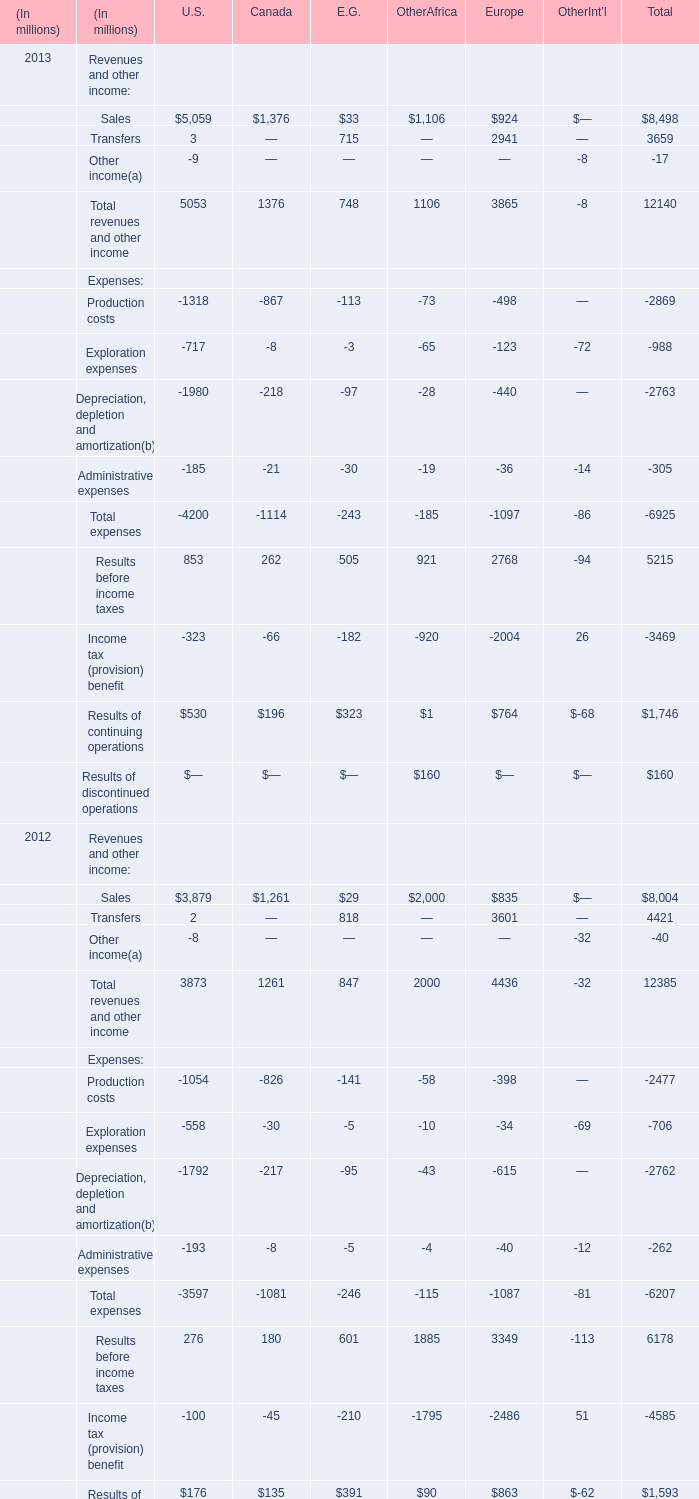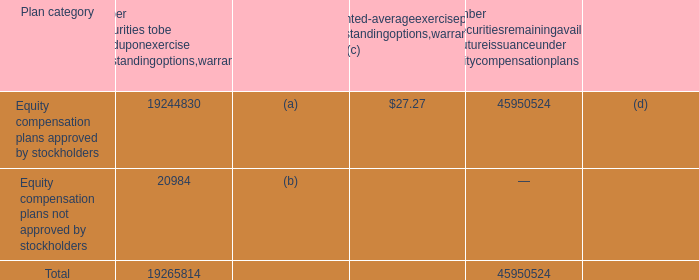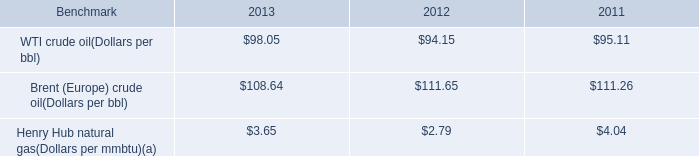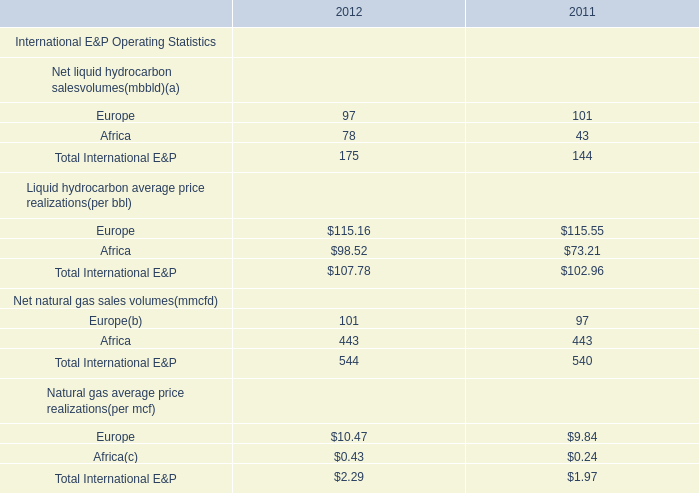by what percentage did the average price of wti crude oil increase from 2011 to 2013? 
Computations: ((98.05 - 95.11) / 95.11)
Answer: 0.03091. 